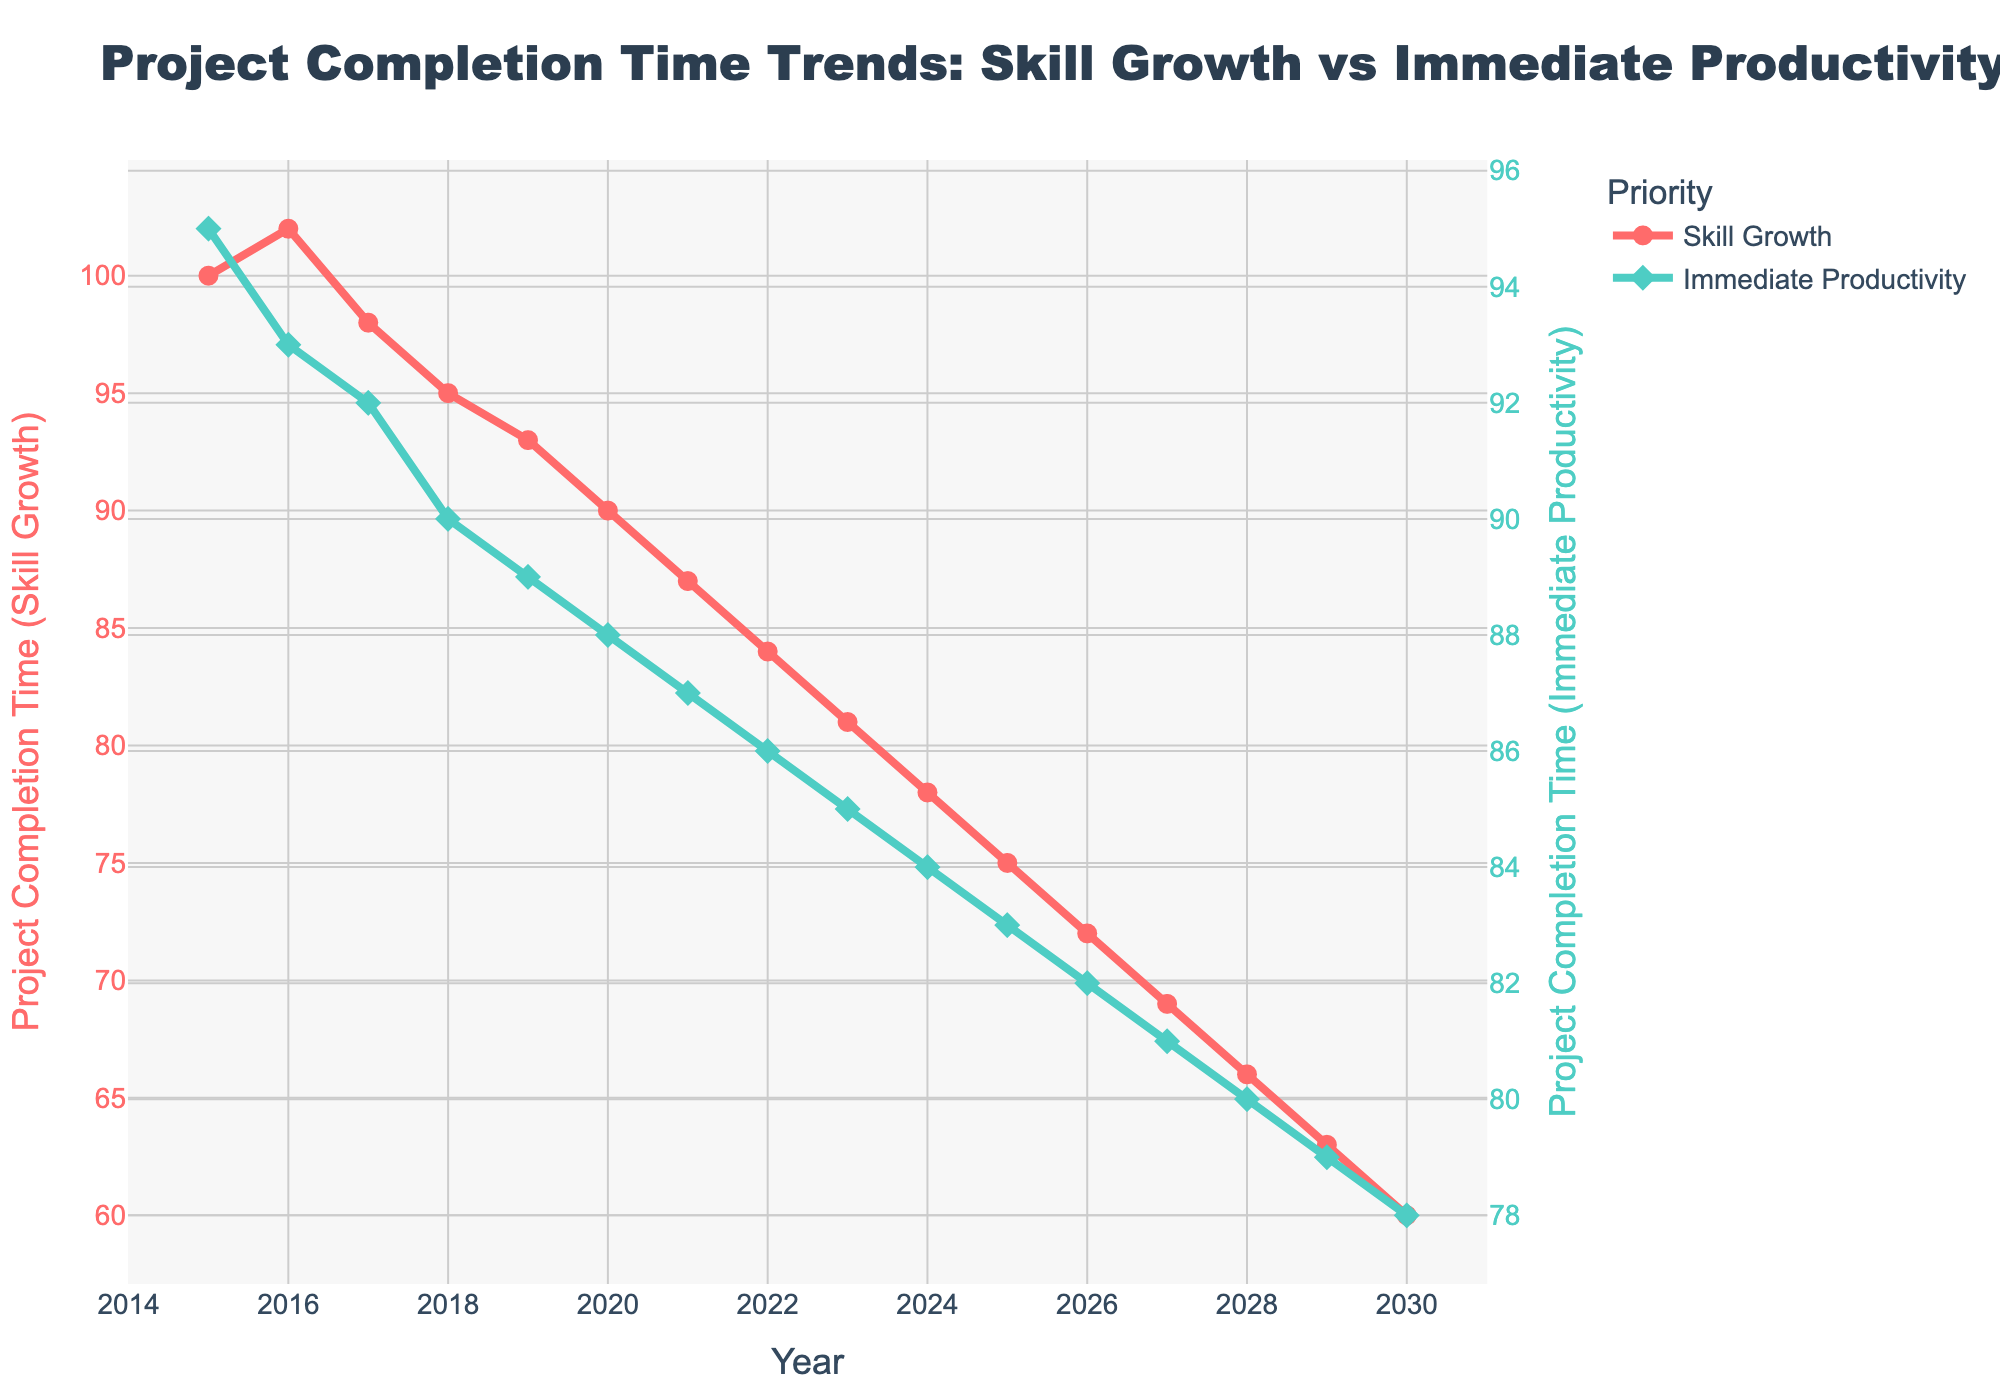What is the decrease in project completion time for "Skill Growth Prioritized" from 2015 to 2030? To find the decrease, subtract the project completion time in 2030 from that in 2015: 100 (2015) - 60 (2030) = 40.
Answer: 40 What is the project completion time for "Immediate Productivity Prioritized" in 2023? The graph shows that the project completion time for "Immediate Productivity Prioritized" in 2023 is 85.
Answer: 85 By how many years does "Skill Growth Prioritized" project completion time decrease steadily after 2021 compared to "Immediate Productivity Prioritized"? Between 2021 and 2030, the completion time for "Skill Growth Prioritized" drops from 87 to 60, a span of 27 units over 9 years. "Immediate Productivity Prioritized" drops from 87 to 78, a span of 9 units over 9 years. Thus, the decrease for "Skill Growth Prioritized" is 27/9 = 3 units per year compared to 9/9 = 1 unit per year for "Immediate Productivity Prioritized".
Answer: 2 units per year Which prioritization shows a consistent decrease in project completion time throughout the years depicted in the graph? The "Skill Growth Prioritized" line continuously decreases from 2015 to 2030 without any increase or stagnation.
Answer: Skill Growth Prioritized In which year do both "Skill Growth Prioritized" and "Immediate Productivity Prioritized" have the same project completion time, and what is it? Both lines intersect in 2021 showing the same project completion time of 87.
Answer: 2021, 87 What is the average project completion time for "Immediate Productivity Prioritized" from 2015 to 2020? Sum the values for "Immediate Productivity Prioritized" from 2015 to 2020 (95+93+92+90+89+88) and then divide by 6: (95 + 93 + 92 + 90+ 89 + 88) / 6 = 547 / 6 ≈ 91.17.
Answer: 91.17 Which prioritization strategy shows a quicker improvement in project completion time from 2015 to 2020? Calculate the decrease in time for both strategies from 2015 to 2020: "Skill Growth Prioritized" goes from 100 to 90, a decrease of 10 units; "Immediate Productivity Prioritized" goes from 95 to 88, a decrease of 7 units. Therefore, "Skill Growth Prioritized" shows a quicker improvement.
Answer: Skill Growth Prioritized What is the total reduction in project completion time for "Immediate Productivity Prioritized" between 2015 and 2030? Subtract the project completion time in 2030 from that in 2015: 95 (2015) - 78 (2030) = 17.
Answer: 17 How does the visual presentation (color and symbols) distinguish "Skill Growth Prioritized" from "Immediate Productivity Prioritized"? "Skill Growth Prioritized" is represented by red lines and circle markers, while "Immediate Productivity Prioritized" is represented by green lines and diamond markers.
Answer: Red with circles, Green with diamonds If one were to overlook the colors and markers, how could they still differentiate between "Skill Growth Prioritized" and "Immediate Productivity Prioritized"? By observing the y-axis titles; the left y-axis corresponds to "Skill Growth Prioritized" and the right y-axis corresponds to "Immediate Productivity Prioritized".
Answer: Y-axis labels 